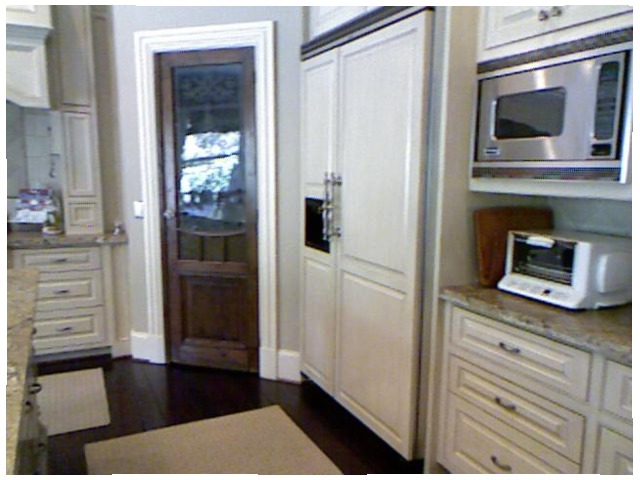<image>
Is there a microwave above the toaster oven? Yes. The microwave is positioned above the toaster oven in the vertical space, higher up in the scene. Is there a mirror next to the door? Yes. The mirror is positioned adjacent to the door, located nearby in the same general area. 